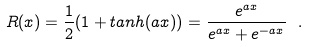Convert formula to latex. <formula><loc_0><loc_0><loc_500><loc_500>R ( x ) = \frac { 1 } { 2 } ( 1 + t a n h ( a x ) ) = \frac { e ^ { a x } } { e ^ { a x } + e ^ { - a x } } \ .</formula> 